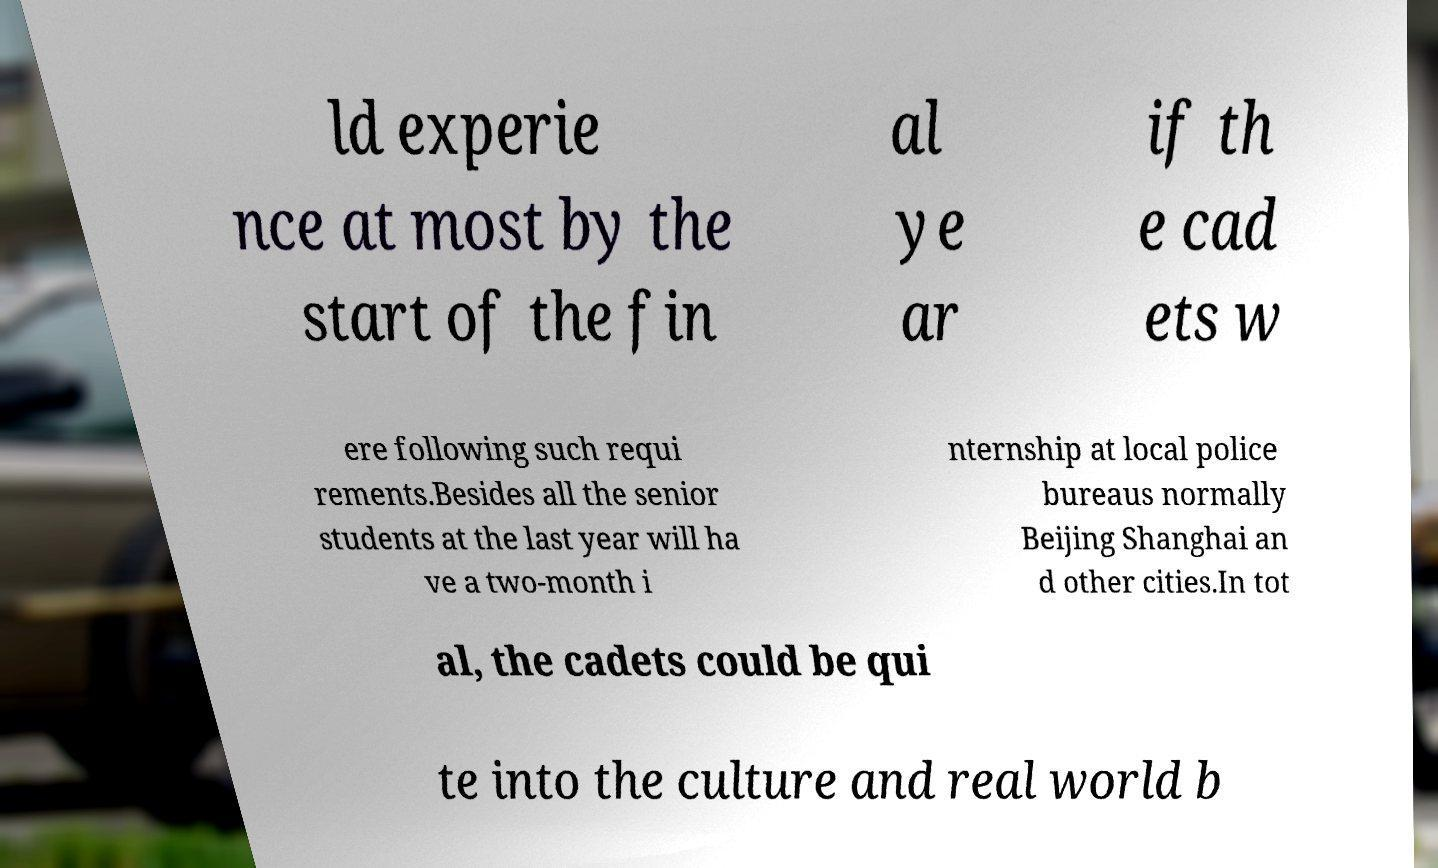Can you accurately transcribe the text from the provided image for me? ld experie nce at most by the start of the fin al ye ar if th e cad ets w ere following such requi rements.Besides all the senior students at the last year will ha ve a two-month i nternship at local police bureaus normally Beijing Shanghai an d other cities.In tot al, the cadets could be qui te into the culture and real world b 